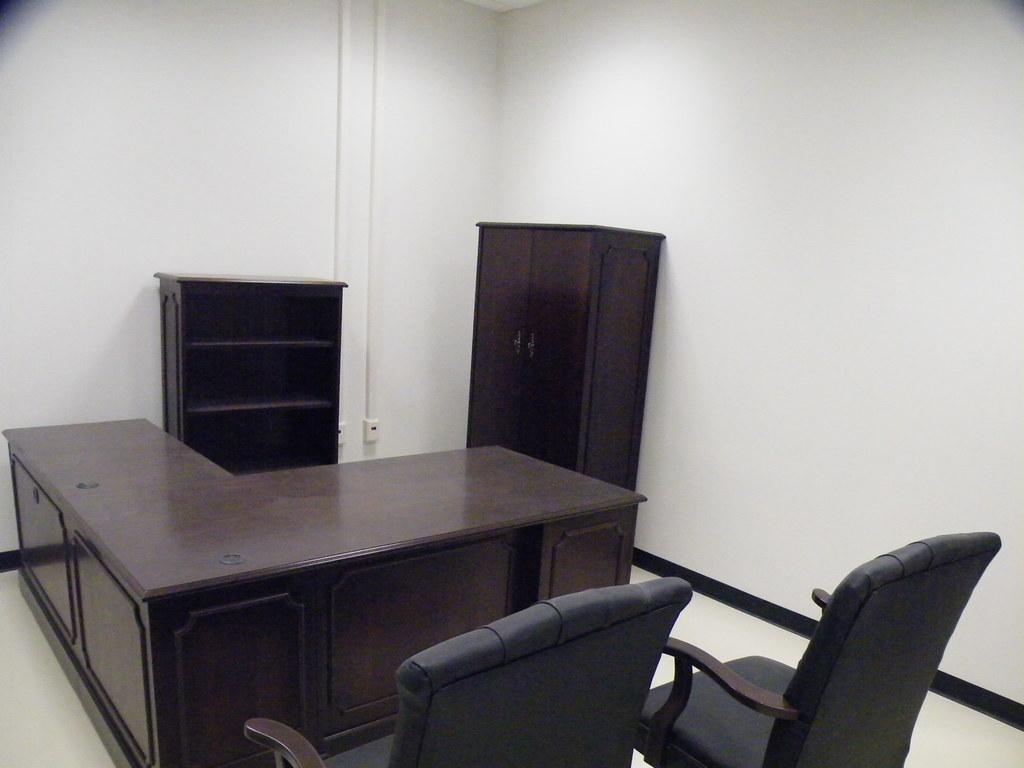What type of furniture is present in the image? There is a table, a chair, and a cupboard in the image. Is there any storage space visible in the image? Yes, there is a cupboard and a rack in the image. How many eggs are on the table in the image? There are no eggs present in the image. What type of footwear is visible on the boys in the image? There are no boys or footwear visible in the image. 